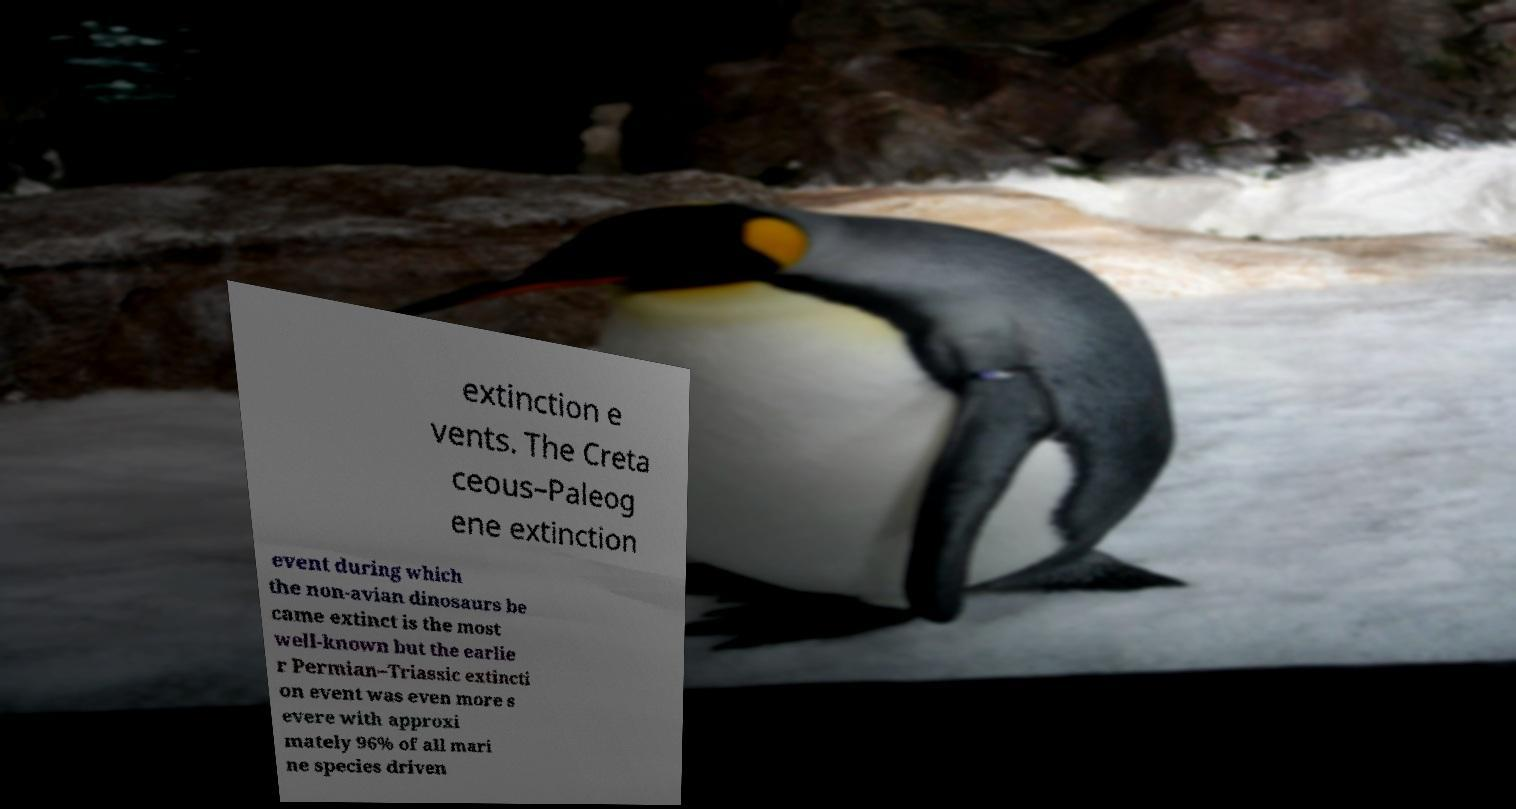Please identify and transcribe the text found in this image. extinction e vents. The Creta ceous–Paleog ene extinction event during which the non-avian dinosaurs be came extinct is the most well-known but the earlie r Permian–Triassic extincti on event was even more s evere with approxi mately 96% of all mari ne species driven 